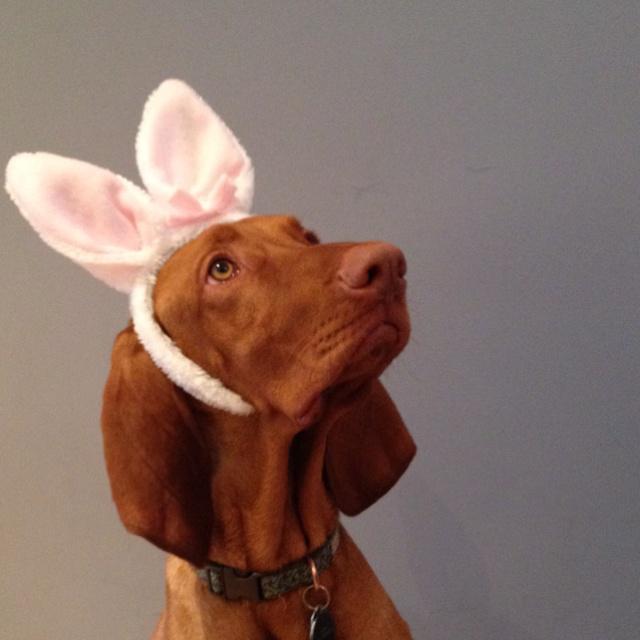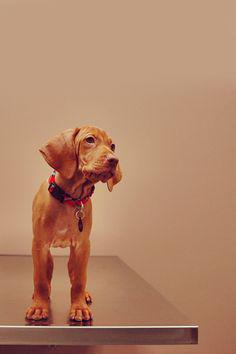The first image is the image on the left, the second image is the image on the right. Examine the images to the left and right. Is the description "The left and right image contains the same number of dogs with one puppy and one adult." accurate? Answer yes or no. Yes. 